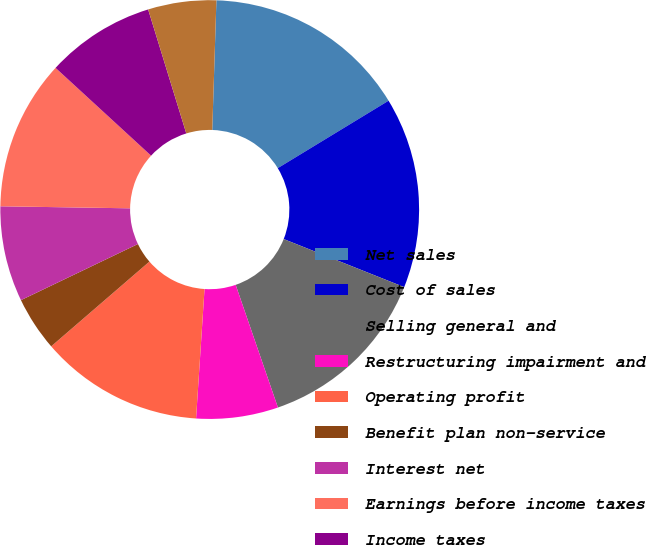Convert chart. <chart><loc_0><loc_0><loc_500><loc_500><pie_chart><fcel>Net sales<fcel>Cost of sales<fcel>Selling general and<fcel>Restructuring impairment and<fcel>Operating profit<fcel>Benefit plan non-service<fcel>Interest net<fcel>Earnings before income taxes<fcel>Income taxes<fcel>After-tax earnings from joint<nl><fcel>15.79%<fcel>14.74%<fcel>13.68%<fcel>6.32%<fcel>12.63%<fcel>4.21%<fcel>7.37%<fcel>11.58%<fcel>8.42%<fcel>5.26%<nl></chart> 